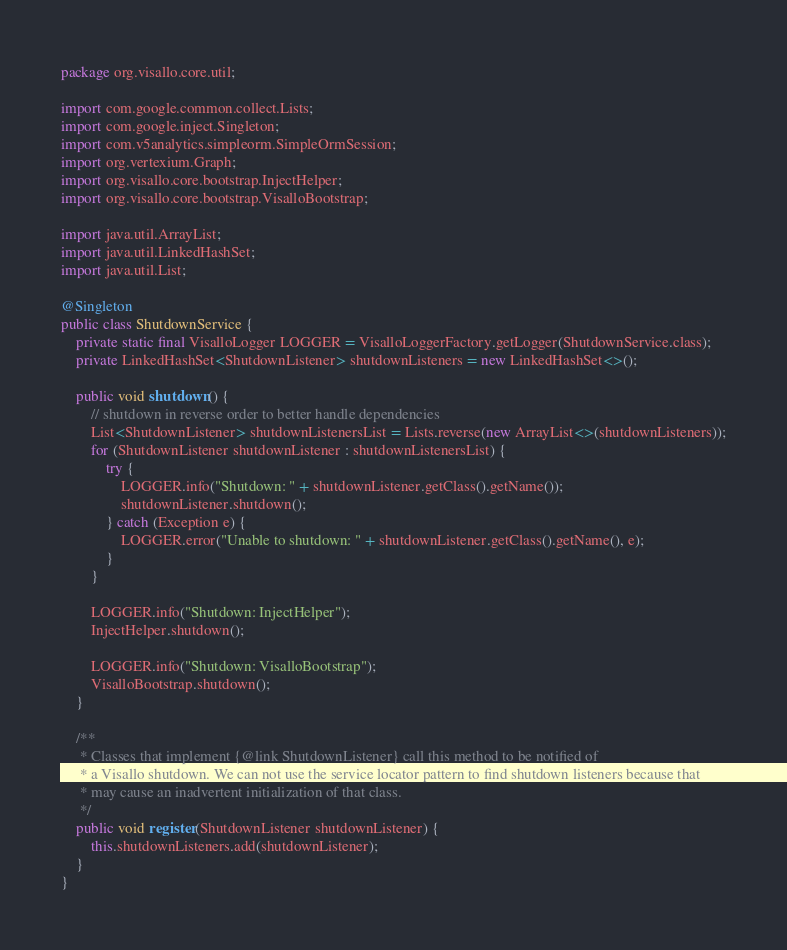<code> <loc_0><loc_0><loc_500><loc_500><_Java_>package org.visallo.core.util;

import com.google.common.collect.Lists;
import com.google.inject.Singleton;
import com.v5analytics.simpleorm.SimpleOrmSession;
import org.vertexium.Graph;
import org.visallo.core.bootstrap.InjectHelper;
import org.visallo.core.bootstrap.VisalloBootstrap;

import java.util.ArrayList;
import java.util.LinkedHashSet;
import java.util.List;

@Singleton
public class ShutdownService {
    private static final VisalloLogger LOGGER = VisalloLoggerFactory.getLogger(ShutdownService.class);
    private LinkedHashSet<ShutdownListener> shutdownListeners = new LinkedHashSet<>();

    public void shutdown() {
        // shutdown in reverse order to better handle dependencies
        List<ShutdownListener> shutdownListenersList = Lists.reverse(new ArrayList<>(shutdownListeners));
        for (ShutdownListener shutdownListener : shutdownListenersList) {
            try {
                LOGGER.info("Shutdown: " + shutdownListener.getClass().getName());
                shutdownListener.shutdown();
            } catch (Exception e) {
                LOGGER.error("Unable to shutdown: " + shutdownListener.getClass().getName(), e);
            }
        }

        LOGGER.info("Shutdown: InjectHelper");
        InjectHelper.shutdown();

        LOGGER.info("Shutdown: VisalloBootstrap");
        VisalloBootstrap.shutdown();
    }

    /**
     * Classes that implement {@link ShutdownListener} call this method to be notified of
     * a Visallo shutdown. We can not use the service locator pattern to find shutdown listeners because that
     * may cause an inadvertent initialization of that class.
     */
    public void register(ShutdownListener shutdownListener) {
        this.shutdownListeners.add(shutdownListener);
    }
}
</code> 